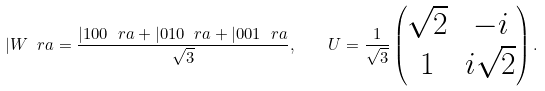<formula> <loc_0><loc_0><loc_500><loc_500>| W \ r a = \frac { | 1 0 0 \ r a + | 0 1 0 \ r a + | 0 0 1 \ r a } { \sqrt { 3 } } , \quad U = \frac { 1 } { \sqrt { 3 } } \begin{pmatrix} \sqrt { 2 } & - i \\ 1 & i \sqrt { 2 } \end{pmatrix} .</formula> 